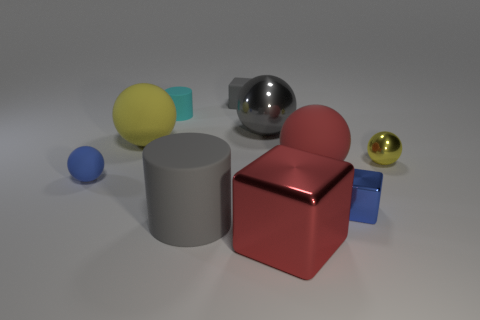How big is the matte thing to the right of the tiny rubber object that is on the right side of the tiny cyan matte cylinder?
Offer a terse response. Large. Is the number of small metal balls to the left of the blue sphere less than the number of small cyan rubber cubes?
Your response must be concise. No. Is the color of the big metal block the same as the small cylinder?
Ensure brevity in your answer.  No. What size is the red block?
Ensure brevity in your answer.  Large. What number of big matte objects are the same color as the rubber block?
Keep it short and to the point. 1. Is there a tiny yellow thing on the right side of the cyan object left of the tiny cube behind the large yellow object?
Provide a succinct answer. Yes. The gray matte object that is the same size as the red metal thing is what shape?
Keep it short and to the point. Cylinder. How many tiny objects are cyan objects or red rubber balls?
Offer a terse response. 1. What is the color of the other large ball that is the same material as the large red ball?
Offer a very short reply. Yellow. There is a gray thing right of the small gray rubber cube; is its shape the same as the small matte object behind the tiny cyan cylinder?
Your response must be concise. No. 